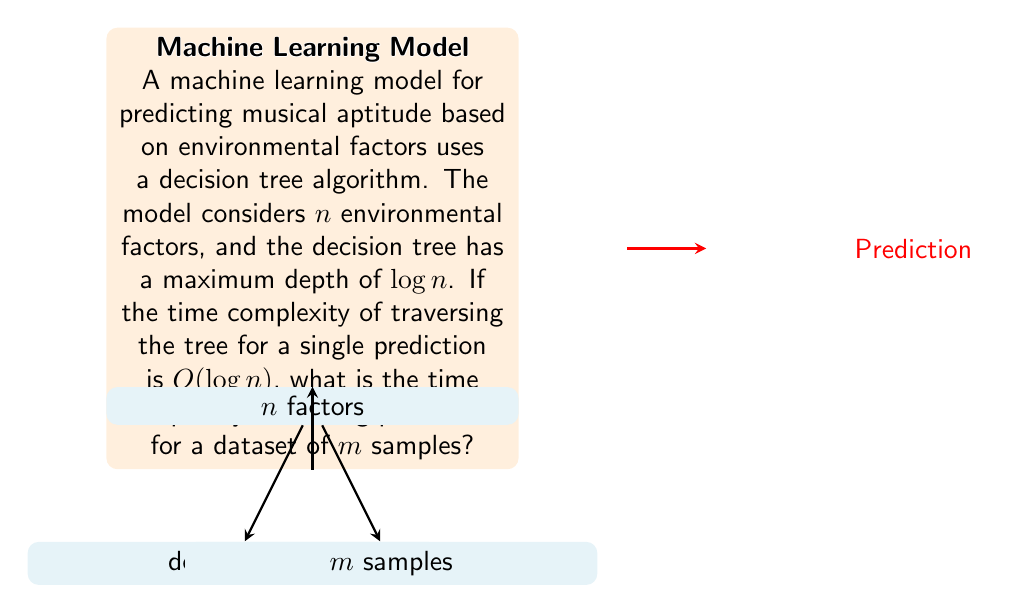Solve this math problem. To solve this problem, let's break it down step-by-step:

1) First, we need to understand what the question is asking:
   - We have a decision tree with depth $\log n$
   - Each prediction (traversal of the tree) takes $O(\log n)$ time
   - We need to make predictions for $m$ samples

2) The time complexity for a single prediction is $O(\log n)$. This means that for each sample, we traverse the tree once, which takes $\log n$ time.

3) We need to make predictions for $m$ samples. This means we need to repeat the tree traversal $m$ times.

4) In algorithm analysis, when we repeat an operation $m$ times, and each operation takes $f(n)$ time, the total time complexity is $O(m \cdot f(n))$.

5) In this case, $f(n) = \log n$ (the time for a single prediction), and we're repeating it $m$ times.

6) Therefore, the total time complexity is:

   $$O(m \cdot \log n)$$

This result makes intuitive sense from a psychological perspective as well. As we increase the number of environmental factors ($n$) we consider, the complexity increases logarithmically, reflecting the diminishing returns of considering additional factors. The linear relationship with $m$ reflects that each additional sample requires an independent prediction.
Answer: $O(m \log n)$ 